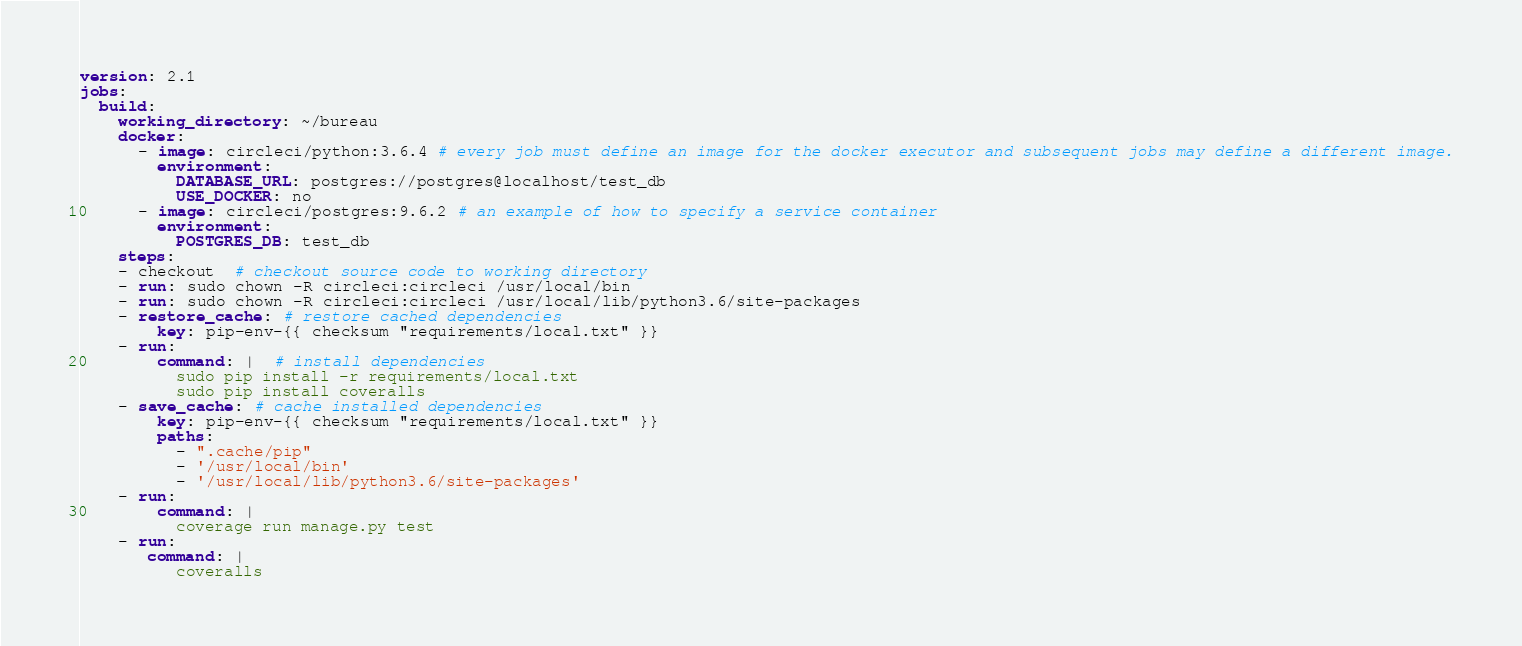<code> <loc_0><loc_0><loc_500><loc_500><_YAML_>version: 2.1
jobs:
  build:
    working_directory: ~/bureau
    docker:
      - image: circleci/python:3.6.4 # every job must define an image for the docker executor and subsequent jobs may define a different image.
        environment:
          DATABASE_URL: postgres://postgres@localhost/test_db
          USE_DOCKER: no
      - image: circleci/postgres:9.6.2 # an example of how to specify a service container
        environment:
          POSTGRES_DB: test_db
    steps:
    - checkout  # checkout source code to working directory
    - run: sudo chown -R circleci:circleci /usr/local/bin
    - run: sudo chown -R circleci:circleci /usr/local/lib/python3.6/site-packages
    - restore_cache: # restore cached dependencies
        key: pip-env-{{ checksum "requirements/local.txt" }}
    - run:
        command: |  # install dependencies
          sudo pip install -r requirements/local.txt
          sudo pip install coveralls
    - save_cache: # cache installed dependencies
        key: pip-env-{{ checksum "requirements/local.txt" }}
        paths:
          - ".cache/pip"
          - '/usr/local/bin'
          - '/usr/local/lib/python3.6/site-packages'
    - run:
        command: |
          coverage run manage.py test
    - run:
       command: |
          coveralls



</code> 